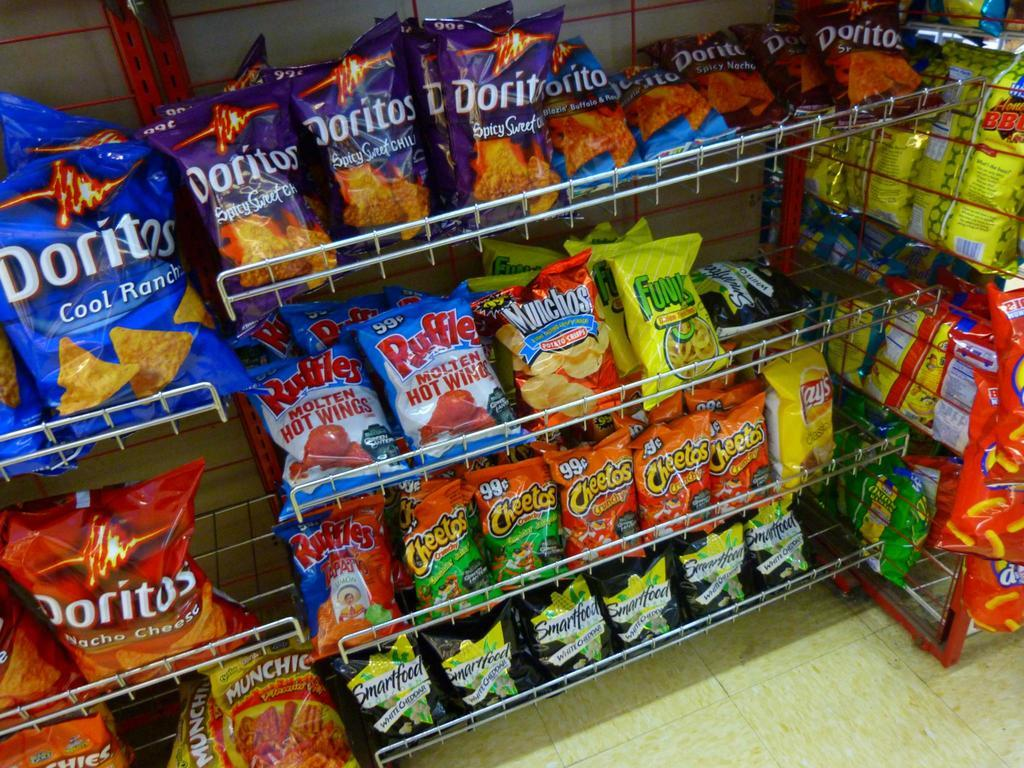<image>
Write a terse but informative summary of the picture. The third shelf from the bottom shelf have Ruffles Molten Hot Wing chips and  Munchos. 